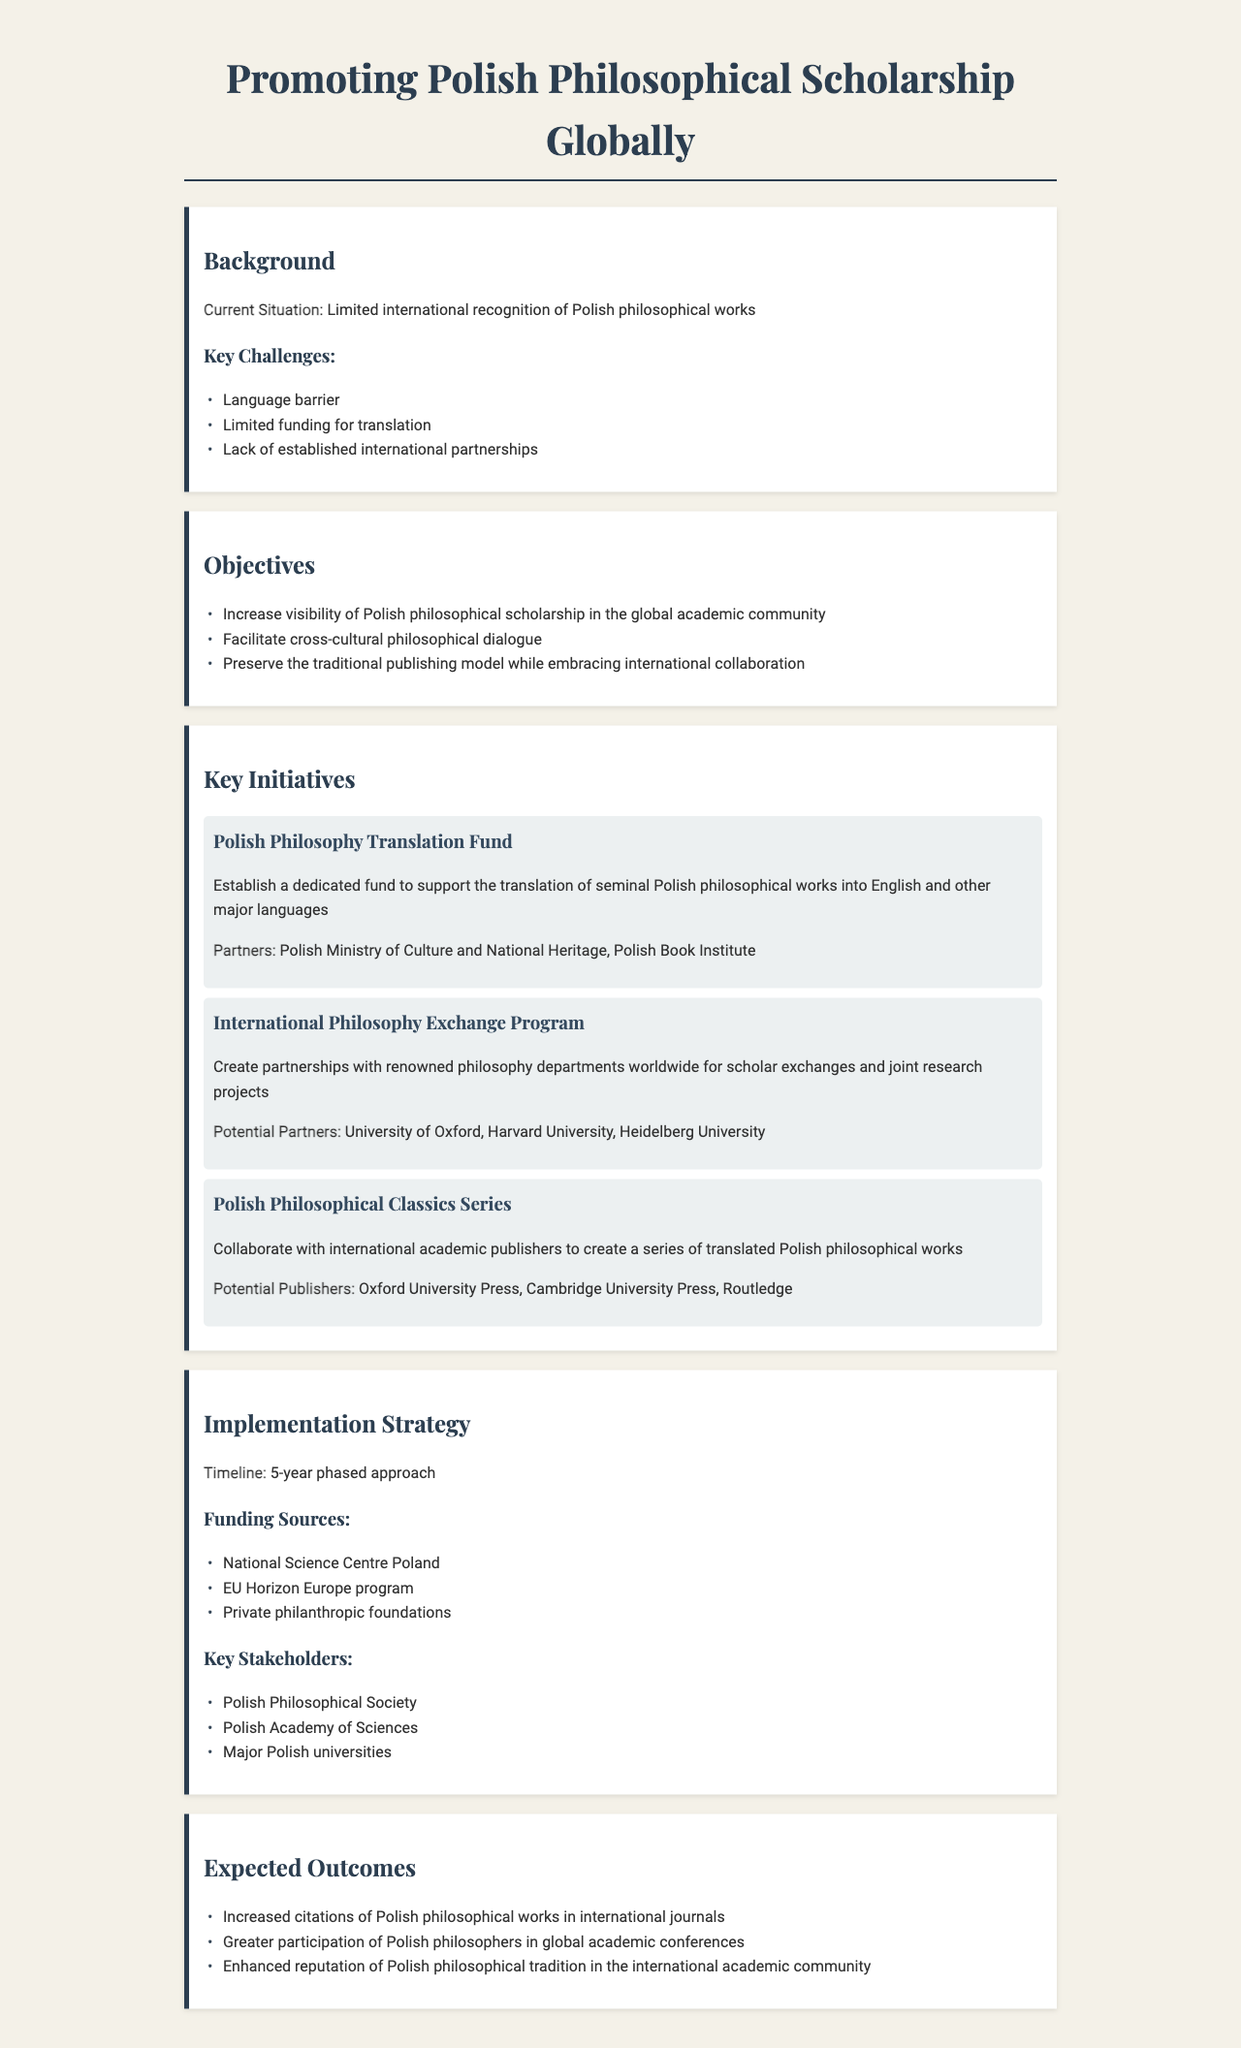What is the title of the policy document? The title of the document is prominently displayed at the top of the rendered document.
Answer: Promoting Polish Philosophical Scholarship Globally What is one key challenge highlighted in the document? The document lists challenges related to the current situation of Polish philosophical works.
Answer: Language barrier What initiative establishes a fund for translation? This initiative is aimed specifically at supporting translation efforts for Polish philosophical works.
Answer: Polish Philosophy Translation Fund Which organization is a partner for the International Philosophy Exchange Program? The document lists potential partners for this initiative.
Answer: Harvard University What is the timeline for the implementation strategy? The document specifies the duration of the phased approach for implementation.
Answer: 5-year phased approach What are the expected outcomes related to citations? This outcome involves the scholarly recognition of Polish philosophical works in academic literature.
Answer: Increased citations of Polish philosophical works in international journals What type of publishing model does the policy aim to preserve? The document discusses a balance between traditional practices and international outreach.
Answer: Traditional publishing model How many key stakeholders are listed in the document? The document provides a list detailing the main stakeholders involved in the implementation.
Answer: Three 